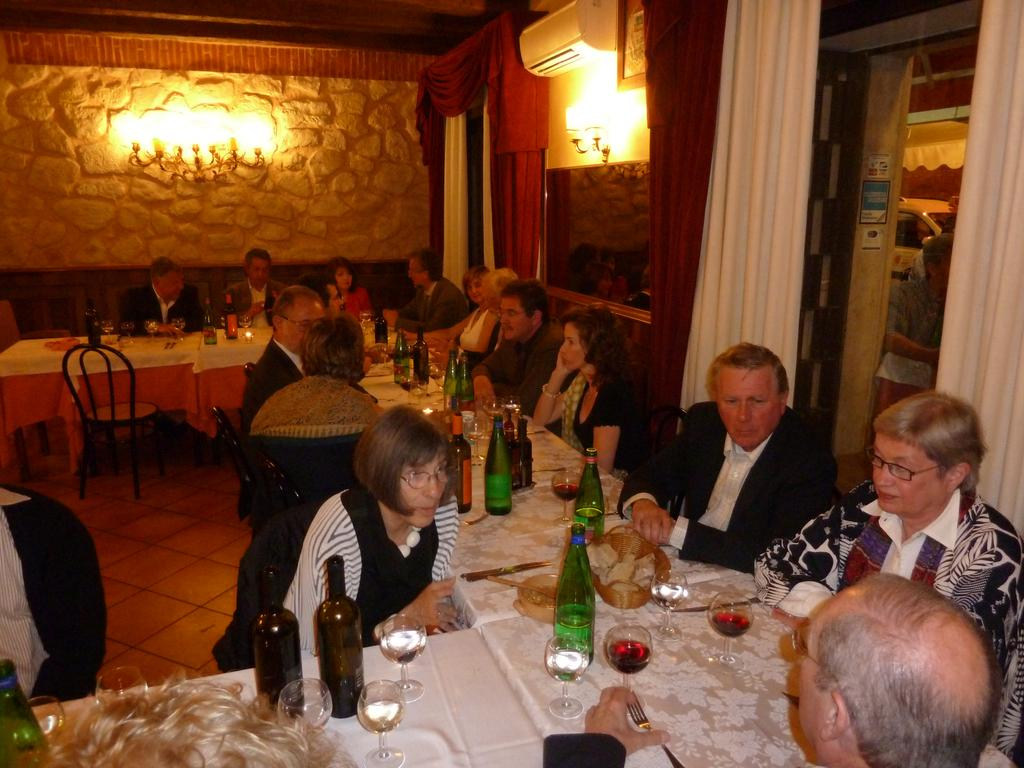What are the people in the image doing? The people in the image are sitting on chairs at a table. What can be seen on the table? There are wine bottles, spoons, and forks on the table. What can be seen in the background of the image? There is a wall, lights, curtains, windows, and an AC in the background. How many leaves are on the elbow of the person sitting at the table? There are no leaves present in the image, and the people's elbows are not visible. What type of celebration is happening in the image? There is no indication of a birthday or any other celebration in the image. 